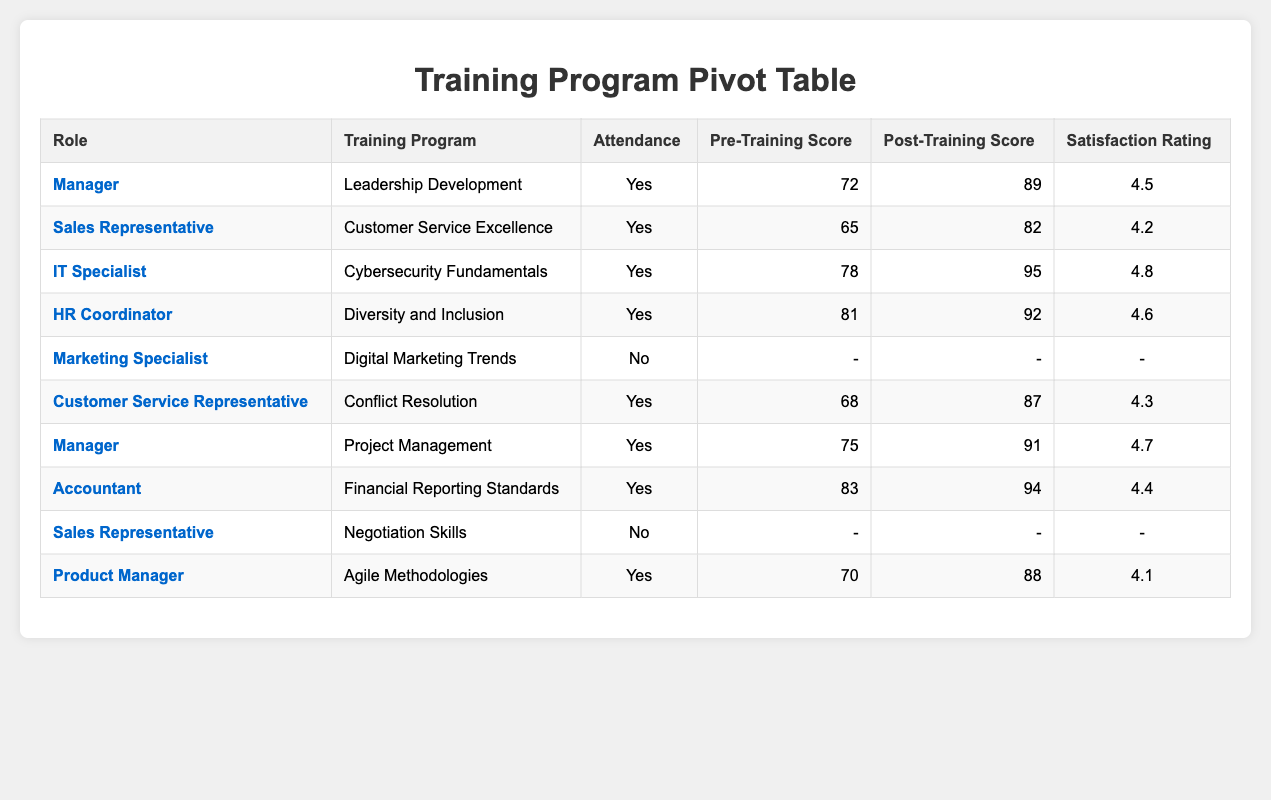What is the post-training score for the IT Specialist? The table has a row for the IT Specialist with the training program "Cybersecurity Fundamentals." The post-training score listed for this role is 95.
Answer: 95 Which training program had the highest satisfaction rating? By examining the satisfaction ratings for each training program, the program "Cybersecurity Fundamentals" has the highest rating at 4.8.
Answer: Cybersecurity Fundamentals How many employees attended the training programs? The table lists attendance for each employee. Counting only the rows with "Yes" for attendance, a total of 7 employees attended the training programs.
Answer: 7 What is the average pre-training score for all employees that attended training? To calculate the average, sum the pre-training scores of attending employees: (72 + 65 + 78 + 81 + 68 + 75 + 83 + 70) =  594. There are 8 scores, so the average score is 594 / 8 = 74.25.
Answer: 74.25 Did any Sales Representatives attend the training programs? The table shows two Sales Representatives: Sarah Johnson and Thomas Brown. Sarah attended (Yes), while Thomas did not (No). So, yes, there was at least one Sales Representative who attended.
Answer: Yes What is the difference between the highest and lowest pre-training scores among the attendees? The highest pre-training score is 83 (Accountant) and the lowest is 65 (Sales Representative). The difference is 83 - 65 = 18.
Answer: 18 Which role had the highest post-training score? The table shows the post-training scores for various roles. The IT Specialist has the highest post-training score of 95.
Answer: IT Specialist What was the satisfaction rating for the Manager in the "Leadership Development" program? The Manager listed in the table for the "Leadership Development" program has a satisfaction rating of 4.5.
Answer: 4.5 